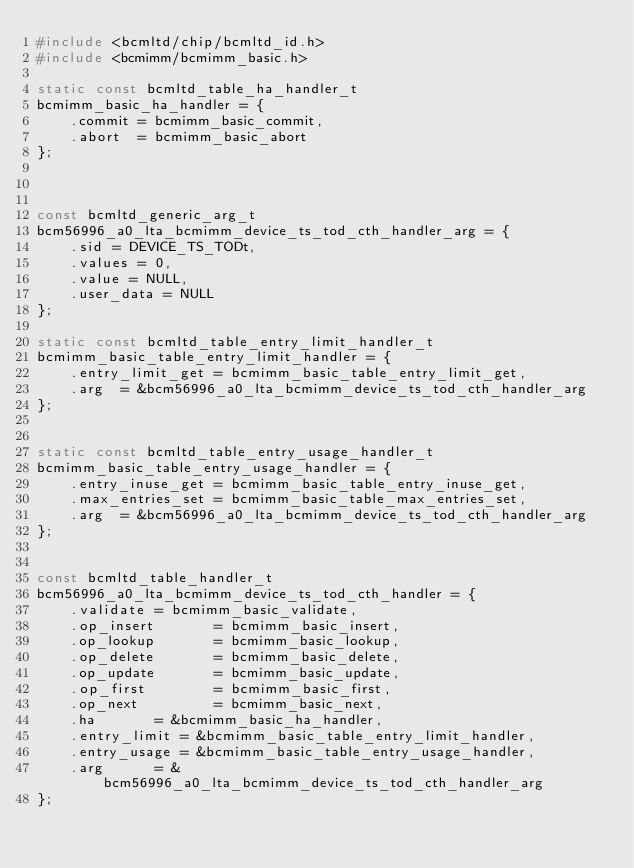Convert code to text. <code><loc_0><loc_0><loc_500><loc_500><_C_>#include <bcmltd/chip/bcmltd_id.h>
#include <bcmimm/bcmimm_basic.h>

static const bcmltd_table_ha_handler_t
bcmimm_basic_ha_handler = {
    .commit = bcmimm_basic_commit,
    .abort  = bcmimm_basic_abort
};



const bcmltd_generic_arg_t
bcm56996_a0_lta_bcmimm_device_ts_tod_cth_handler_arg = {
    .sid = DEVICE_TS_TODt,
    .values = 0,
    .value = NULL,
    .user_data = NULL
};

static const bcmltd_table_entry_limit_handler_t
bcmimm_basic_table_entry_limit_handler = {
    .entry_limit_get = bcmimm_basic_table_entry_limit_get,
    .arg  = &bcm56996_a0_lta_bcmimm_device_ts_tod_cth_handler_arg
};


static const bcmltd_table_entry_usage_handler_t
bcmimm_basic_table_entry_usage_handler = {
    .entry_inuse_get = bcmimm_basic_table_entry_inuse_get,
    .max_entries_set = bcmimm_basic_table_max_entries_set,
    .arg  = &bcm56996_a0_lta_bcmimm_device_ts_tod_cth_handler_arg
};


const bcmltd_table_handler_t
bcm56996_a0_lta_bcmimm_device_ts_tod_cth_handler = {
    .validate = bcmimm_basic_validate,
    .op_insert       = bcmimm_basic_insert,
    .op_lookup       = bcmimm_basic_lookup,
    .op_delete       = bcmimm_basic_delete,
    .op_update       = bcmimm_basic_update,
    .op_first        = bcmimm_basic_first,
    .op_next         = bcmimm_basic_next,
    .ha       = &bcmimm_basic_ha_handler,
    .entry_limit = &bcmimm_basic_table_entry_limit_handler,
    .entry_usage = &bcmimm_basic_table_entry_usage_handler,
    .arg      = &bcm56996_a0_lta_bcmimm_device_ts_tod_cth_handler_arg
};

</code> 